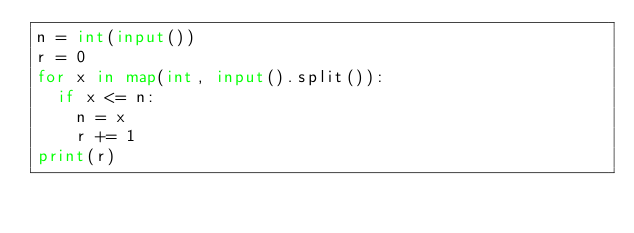<code> <loc_0><loc_0><loc_500><loc_500><_Python_>n = int(input())
r = 0
for x in map(int, input().split()):
  if x <= n:
    n = x
    r += 1
print(r)
</code> 